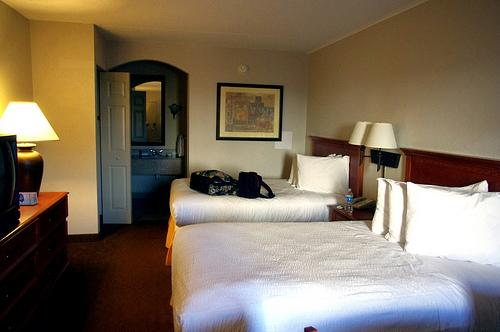Describe the items in the image that help create a sense of relaxation and comfort. The comfortable beds with white bedding and pillows, soft lighting from the lamps on the wall and dresser, and the inviting open door make for a relaxing hotel room. Mention the prominent elements in the image, highlighting their colors and positions. Two beds with white sheets and pillows in a hotel room, a framed picture on the wall, lamps on the wall and dresser, bags on the bed, opened white door, and mirror in the next room. Discuss the role of color in the image, focusing on the use of white. White is prominently used for the bedding, pillows, and door, giving the hotel room a clean and inviting appearance, while darker colors are found in the bags and picture frame. Describe the image focusing on the wall decorations and the lights. There is a framed picture on the wall, two lamps on the wall between the beds, and other lights are off, creating a dim and comfortable ambiance in the room. List the objects placed on the beds along with the main features of the beds. On the beds, there are white pillows, white sheets, and bags. The beds are a part of a hotel room and have lamps on the wall between them. Provide a brief description of the overall scene depicted in the image. A hotel room with two beds, white bedding, and luggage on the bed, with lamps on the wall and dresser, and an open door revealing a mirror in the next room. Create a sentence that conveys the atmosphere of the image. A cozy hotel room with two beds, white bedding, and a welcoming atmosphere, created by the dim lights, open door, and pleasant decorations. Describe the primary furniture in the image and the objects placed on them. Two beds with white sheets and pillows, bags on one bed, a nightstand with a bottle of water, a dresser with a lamp and television, and lamps on the wall between the beds. Mention the main objects and their locations in the room. Two beds with white bedding are in the center, a framed picture is on the wall, the lamps are on the wall between the beds, and an opened white door is on the left. Talk about the objects in the image related to travel and hospitality. The image portrays a hotel room with two beds, luggage on the bed, and an open door – typical elements of a travel setting and representing the hospitality industry. 